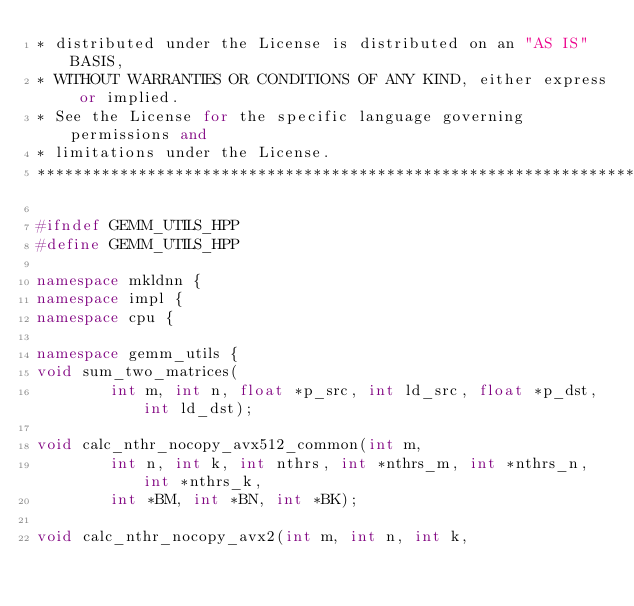Convert code to text. <code><loc_0><loc_0><loc_500><loc_500><_C++_>* distributed under the License is distributed on an "AS IS" BASIS,
* WITHOUT WARRANTIES OR CONDITIONS OF ANY KIND, either express or implied.
* See the License for the specific language governing permissions and
* limitations under the License.
*******************************************************************************/

#ifndef GEMM_UTILS_HPP
#define GEMM_UTILS_HPP

namespace mkldnn {
namespace impl {
namespace cpu {

namespace gemm_utils {
void sum_two_matrices(
        int m, int n, float *p_src, int ld_src, float *p_dst, int ld_dst);

void calc_nthr_nocopy_avx512_common(int m,
        int n, int k, int nthrs, int *nthrs_m, int *nthrs_n, int *nthrs_k,
        int *BM, int *BN, int *BK);

void calc_nthr_nocopy_avx2(int m, int n, int k,</code> 